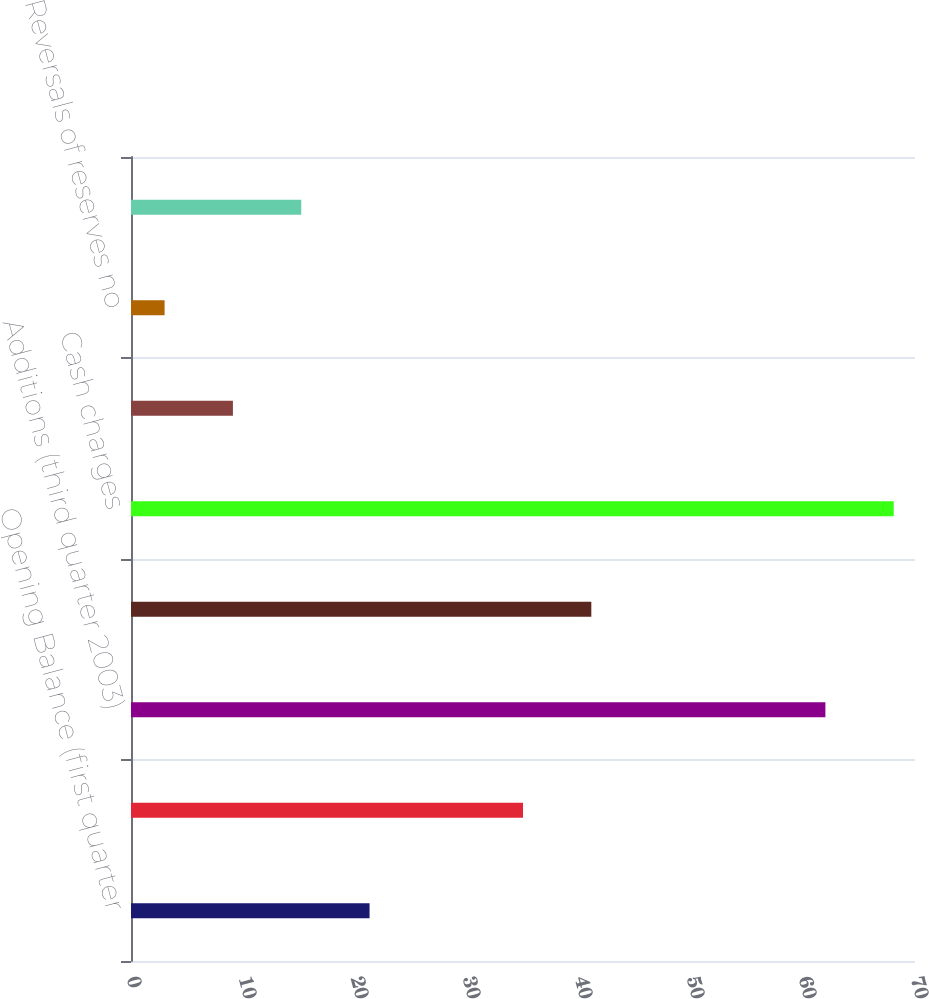Convert chart to OTSL. <chart><loc_0><loc_0><loc_500><loc_500><bar_chart><fcel>Opening Balance (first quarter<fcel>Additions (second quarter<fcel>Additions (third quarter 2003)<fcel>Additions (fourth quarter<fcel>Cash charges<fcel>Pension and postretirement<fcel>Reversals of reserves no<fcel>Environmental<nl><fcel>21.3<fcel>35<fcel>62<fcel>41.1<fcel>68.1<fcel>9.1<fcel>3<fcel>15.2<nl></chart> 